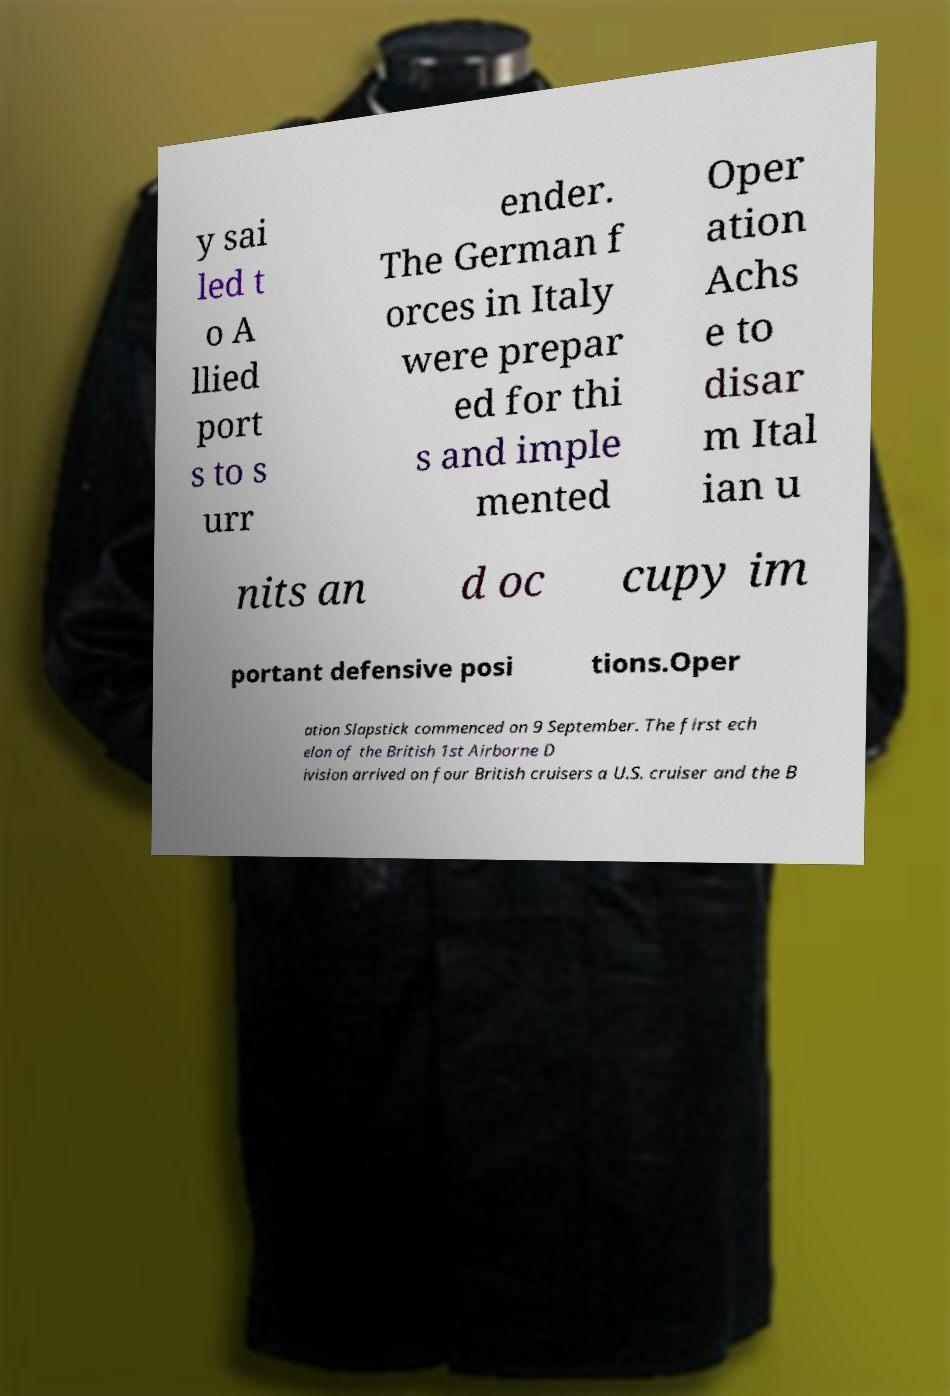Please read and relay the text visible in this image. What does it say? y sai led t o A llied port s to s urr ender. The German f orces in Italy were prepar ed for thi s and imple mented Oper ation Achs e to disar m Ital ian u nits an d oc cupy im portant defensive posi tions.Oper ation Slapstick commenced on 9 September. The first ech elon of the British 1st Airborne D ivision arrived on four British cruisers a U.S. cruiser and the B 